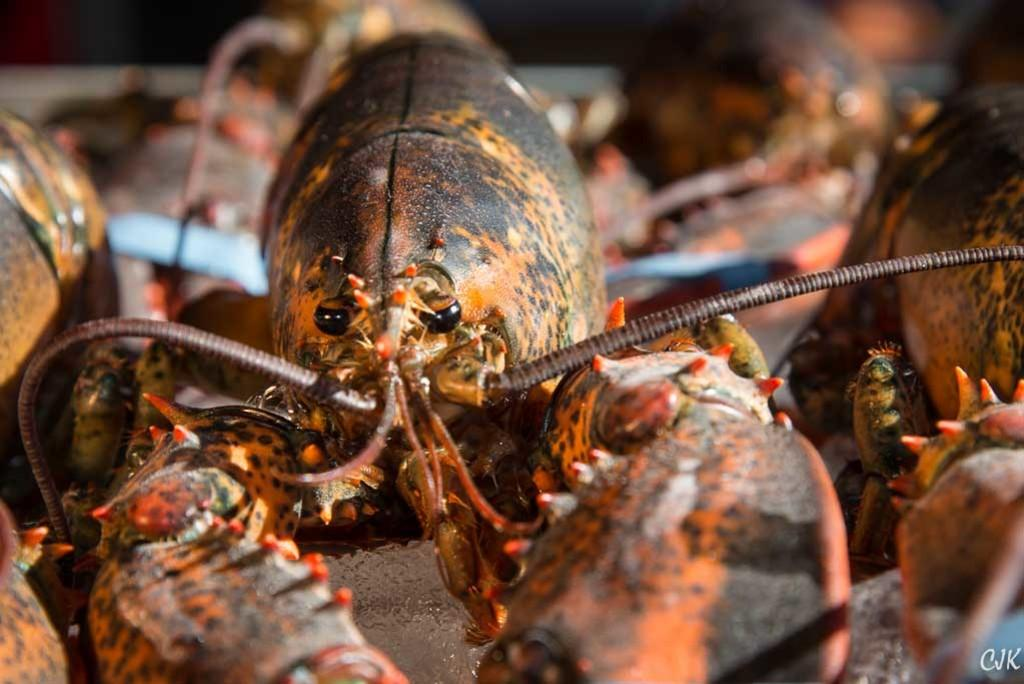What type of animals can be seen on the path in the image? There are lobsters on the path in the image. Can you describe any additional features of the image? Yes, there is a watermark on the image. What advice is the lobster giving to the person in the image? There is no person present in the image, and the lobsters are not giving any advice. 